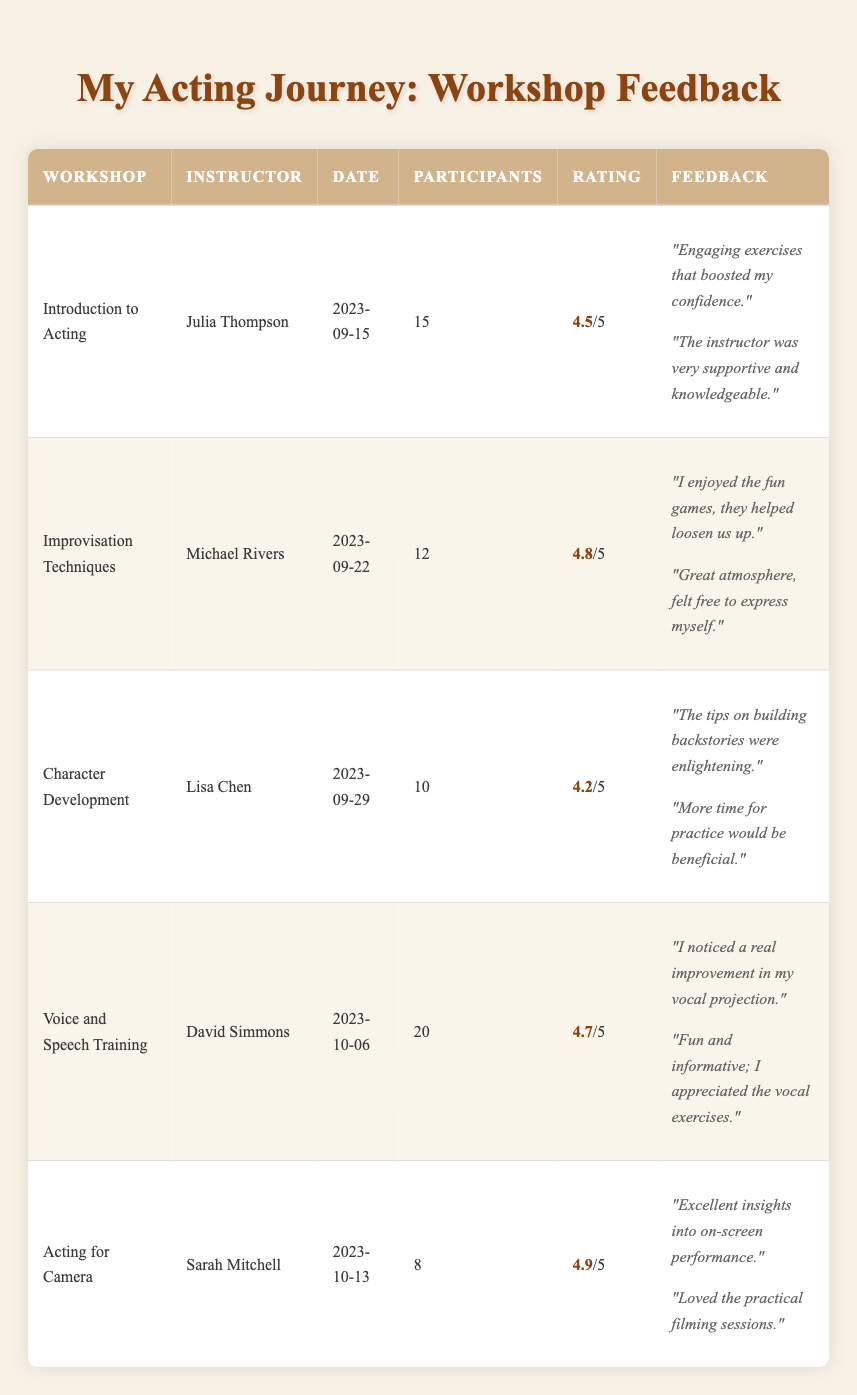What is the highest average rating among the workshops? The average ratings for each workshop are as follows: Introduction to Acting (4.5), Improvisation Techniques (4.8), Character Development (4.2), Voice and Speech Training (4.7), and Acting for Camera (4.9). The highest of these ratings is 4.9 from the Acting for Camera workshop.
Answer: 4.9 Who was the instructor for the improvisation workshop? The workshop titled "Improvisation Techniques" was instructed by Michael Rivers, as listed in the table.
Answer: Michael Rivers How many participants attended the Voice and Speech Training workshop? The table shows that the Voice and Speech Training workshop had 20 participants, clearly stated in the respective row.
Answer: 20 Which workshop had the lowest average rating? The average ratings are: Introduction to Acting (4.5), Improvisation Techniques (4.8), Character Development (4.2), Voice and Speech Training (4.7), and Acting for Camera (4.9). Comparing these ratings, Character Development has the lowest average rating of 4.2.
Answer: Character Development What is the total number of participants across all workshops? To find the total number of participants, we add the participant counts from each workshop: 15 + 12 + 10 + 20 + 8 = 65. Thus, the total number of participants is 65.
Answer: 65 Was there any workshop that had an average rating of 4.6 or higher? Yes, the workshops with average ratings of 4.6 or higher are: Improvisation Techniques (4.8), Voice and Speech Training (4.7), and Acting for Camera (4.9), confirming that there were indeed workshops above that threshold.
Answer: Yes How many feedback comments were provided for the Character Development workshop? The Character Development workshop received two feedback comments as seen in the respective section of the table.
Answer: 2 What is the average rating trend from the Introduction to Acting to the Acting for Camera workshop? The average ratings for the workshops from Introduction to Acting (4.5), Improvisation Techniques (4.8), Character Development (4.2), Voice and Speech Training (4.7), to Acting for Camera (4.9) show a general upward trend, despite a slight dip with Character Development. The trend reflects improvements, particularly from Improvisation Techniques onward.
Answer: Mixed upward trend 